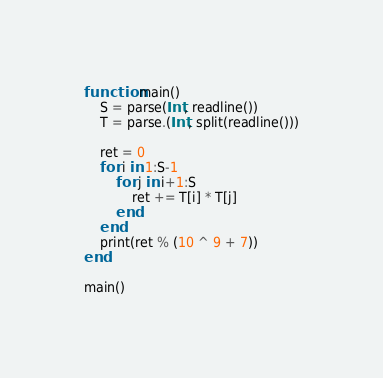<code> <loc_0><loc_0><loc_500><loc_500><_Julia_>function main()
    S = parse(Int, readline())
    T = parse.(Int, split(readline()))

    ret = 0
    for i in 1:S-1
        for j in i+1:S
            ret += T[i] * T[j]
        end
    end
    print(ret % (10 ^ 9 + 7))
end

main()</code> 